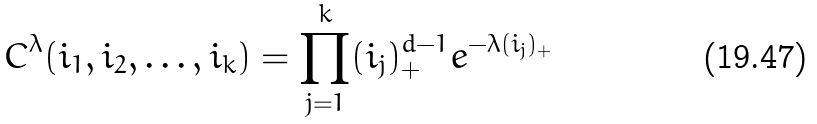<formula> <loc_0><loc_0><loc_500><loc_500>C ^ { \lambda } ( i _ { 1 } , i _ { 2 } , \dots , i _ { k } ) = \prod _ { j = 1 } ^ { k } ( i _ { j } ) ^ { d - 1 } _ { + } e ^ { - \lambda ( i _ { j } ) _ { + } }</formula> 